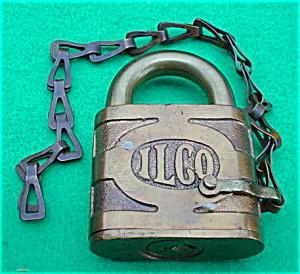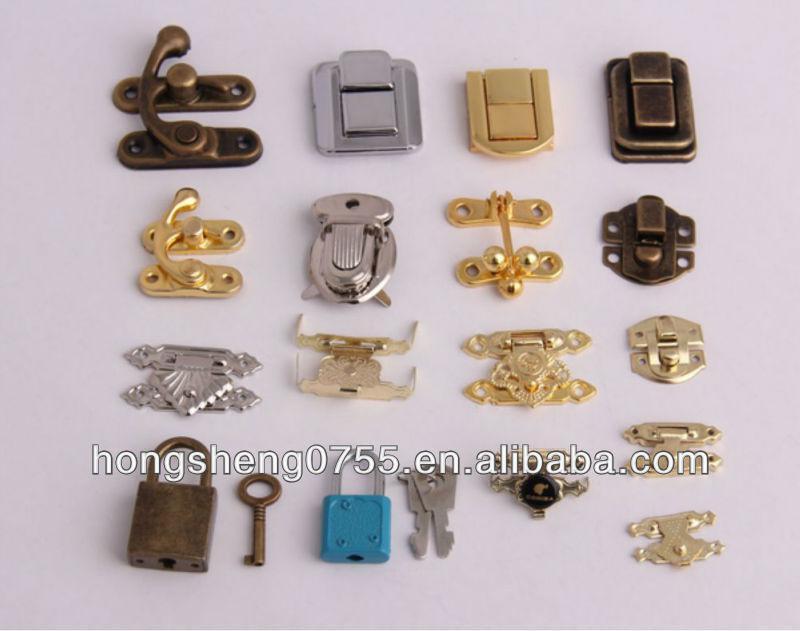The first image is the image on the left, the second image is the image on the right. Analyze the images presented: Is the assertion "There are at least two locks with their keys shown in one of the images." valid? Answer yes or no. Yes. The first image is the image on the left, the second image is the image on the right. Given the left and right images, does the statement "There is one key and one lock in the left image." hold true? Answer yes or no. No. The first image is the image on the left, the second image is the image on the right. Assess this claim about the two images: "There is at least 1 lock with a chain in the right image.". Correct or not? Answer yes or no. No. 